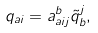<formula> <loc_0><loc_0><loc_500><loc_500>q _ { a i } = a _ { a i j } ^ { b } \tilde { q } _ { b } ^ { j } ,</formula> 